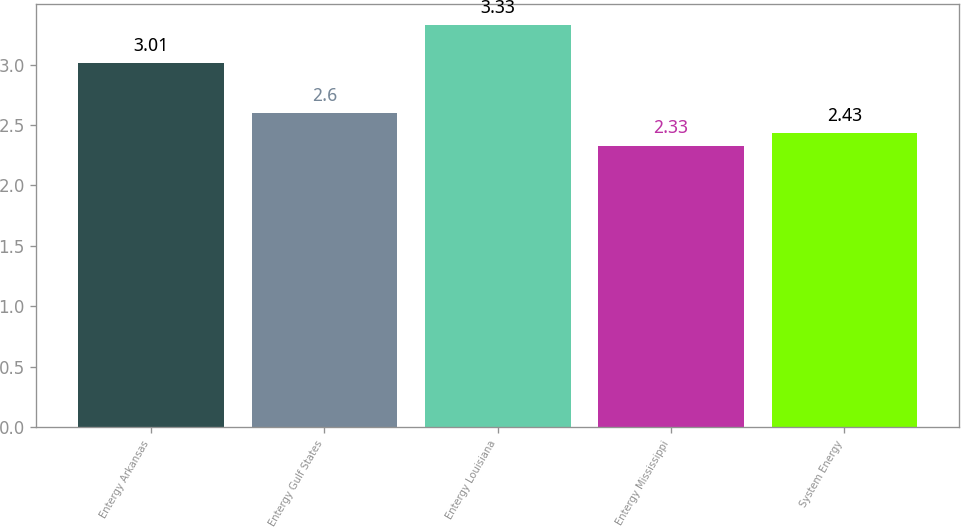Convert chart. <chart><loc_0><loc_0><loc_500><loc_500><bar_chart><fcel>Entergy Arkansas<fcel>Entergy Gulf States<fcel>Entergy Louisiana<fcel>Entergy Mississippi<fcel>System Energy<nl><fcel>3.01<fcel>2.6<fcel>3.33<fcel>2.33<fcel>2.43<nl></chart> 